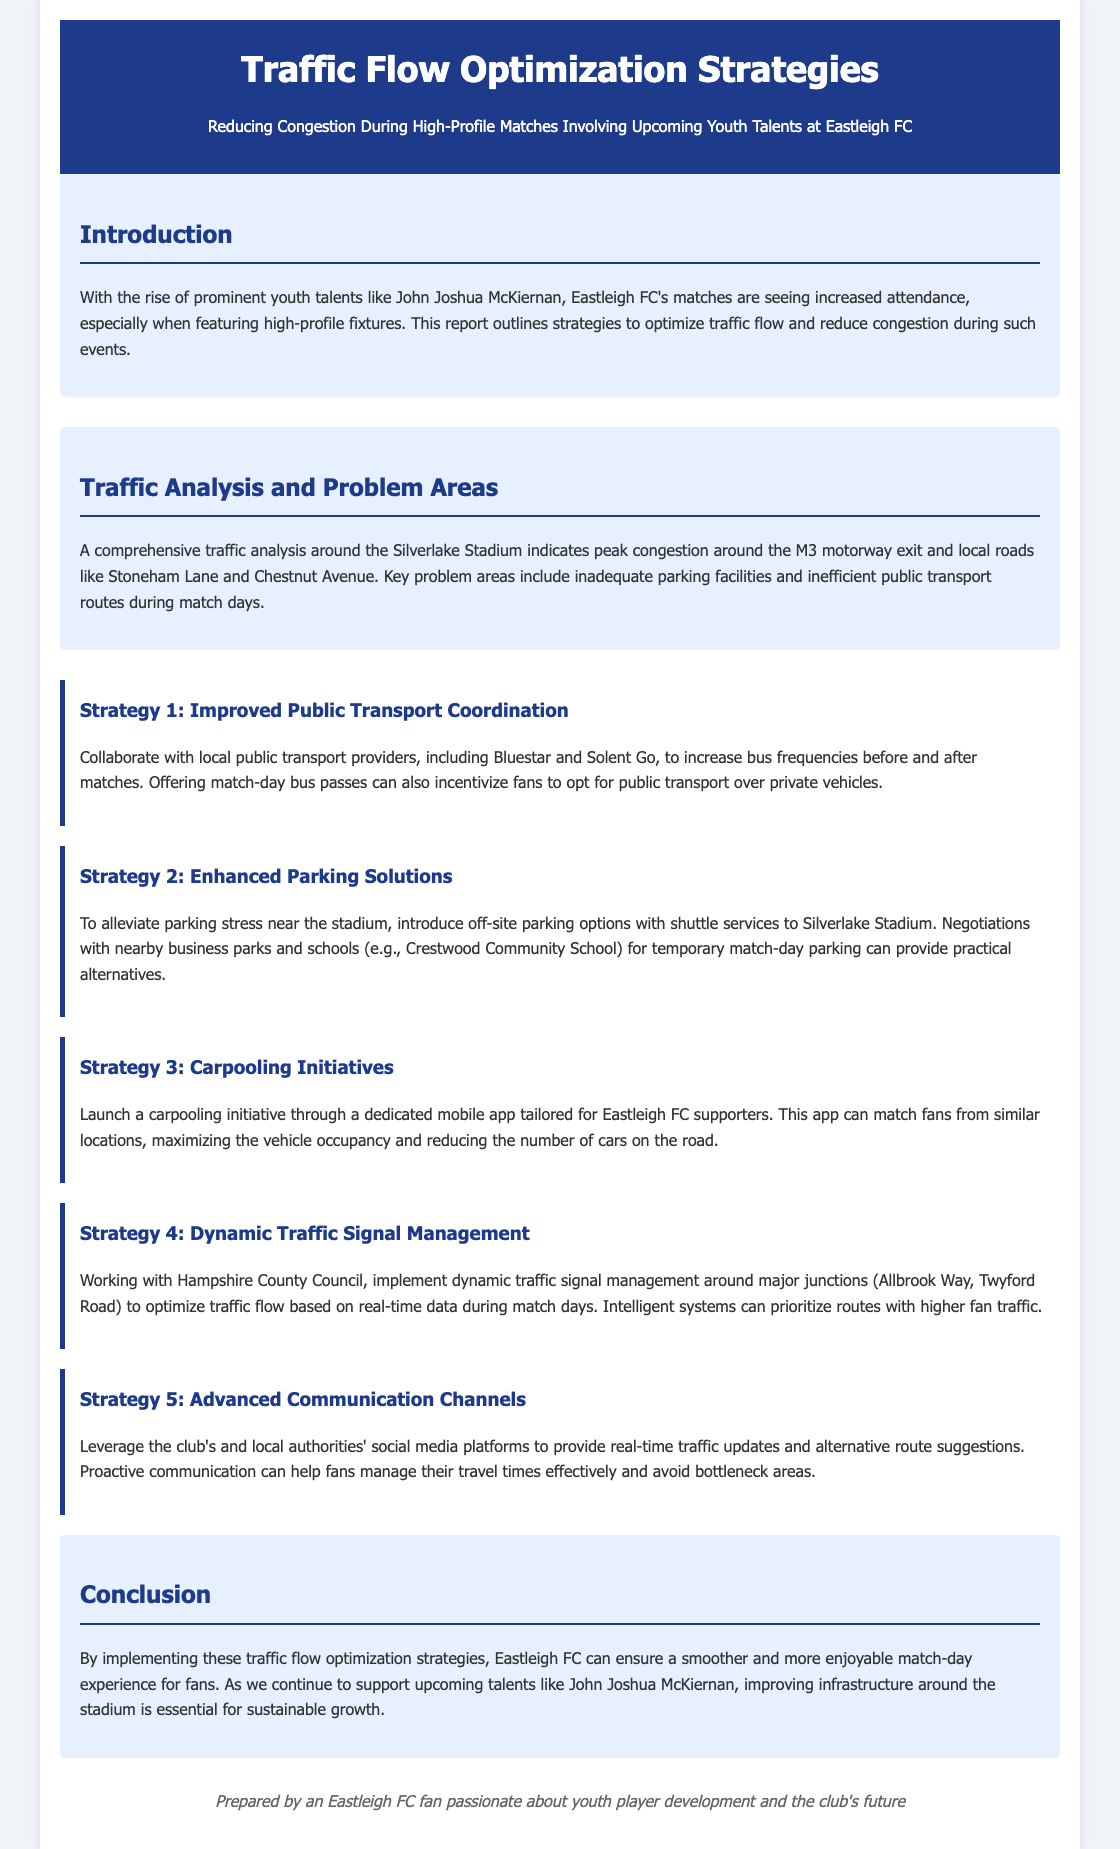What is the title of the report? The title of the report is presented prominently at the top of the document.
Answer: Traffic Flow Optimization Strategies Who is the key youth talent mentioned in the document? The document specifically highlights the rising youth talent associated with Eastleigh FC.
Answer: John Joshua McKiernan What is one suggested solution for public transport? The report suggests specific strategies to improve public transport for match days.
Answer: Increased bus frequencies How many strategies are outlined in the report? The report lists several strategies for traffic flow optimization.
Answer: Five What is one major problem area identified in the traffic analysis? The analysis identifies specific congestion points around the stadium.
Answer: M3 motorway exit Which authority is mentioned for the implementation of traffic signal management? The report discusses collaboration with local authorities for traffic management solutions.
Answer: Hampshire County Council What does the conclusion state about improving infrastructure? The conclusion emphasizes the importance of certain elements for fan experience.
Answer: Essential for sustainable growth What does the introduction mention as leading to increased attendance? The introduction highlights factors contributing to Fan attendance growth.
Answer: Prominent youth talents 